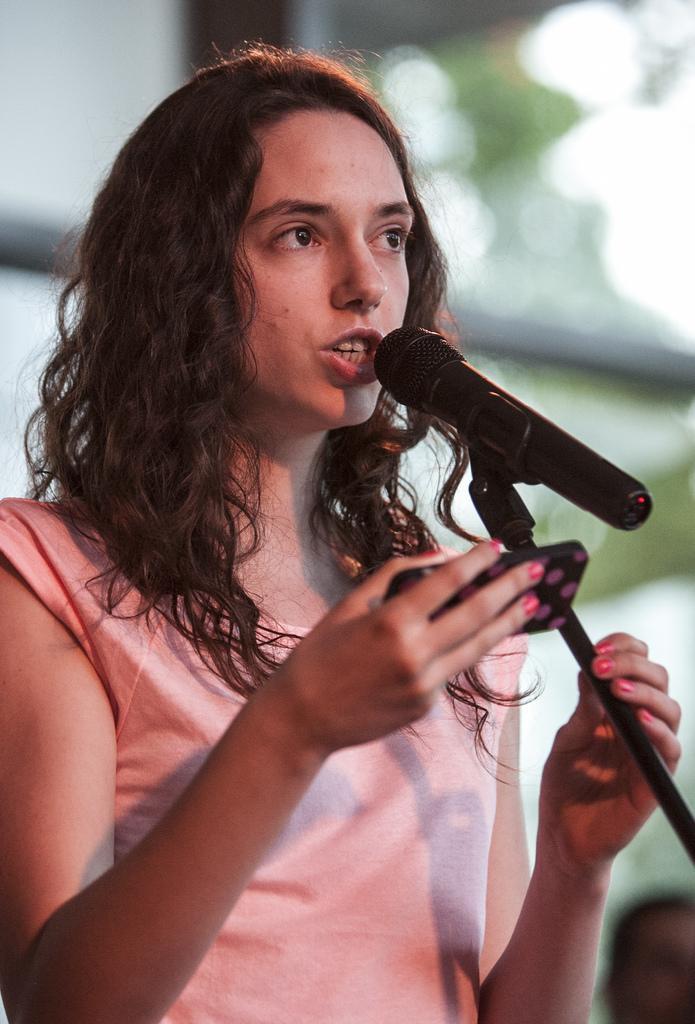Could you give a brief overview of what you see in this image? In this image, there is a person wearing clothes and holding a phone with her hand. There is a mic on the right side of the image. In background, image is blurred. 